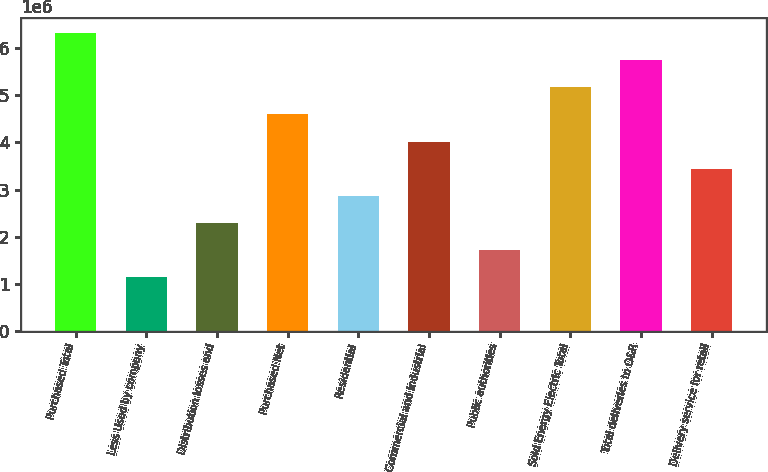Convert chart to OTSL. <chart><loc_0><loc_0><loc_500><loc_500><bar_chart><fcel>Purchased Total<fcel>Less Used by company<fcel>Distribution losses and<fcel>Purchased Net<fcel>Residential<fcel>Commercial and industrial<fcel>Public authorities<fcel>Sold Energy Electric Total<fcel>Total deliveries to O&R<fcel>Delivery service for retail<nl><fcel>6.31681e+06<fcel>1.14852e+06<fcel>2.29703e+06<fcel>4.59405e+06<fcel>2.87128e+06<fcel>4.01979e+06<fcel>1.72277e+06<fcel>5.1683e+06<fcel>5.74255e+06<fcel>3.44554e+06<nl></chart> 